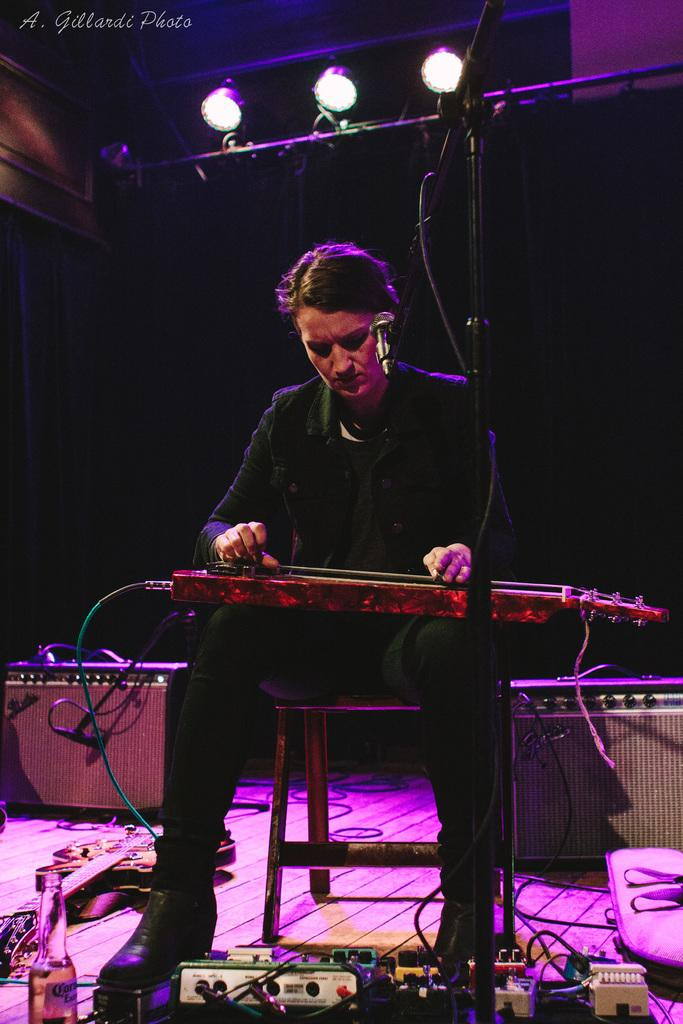What is the person in the image doing? The person is sitting and playing a musical instrument. What can be seen on the floor in the image? There are objects on the floor in the image. What verse is the person reciting while playing the musical instrument in the image? There is no indication in the image that the person is reciting a verse while playing the musical instrument. 